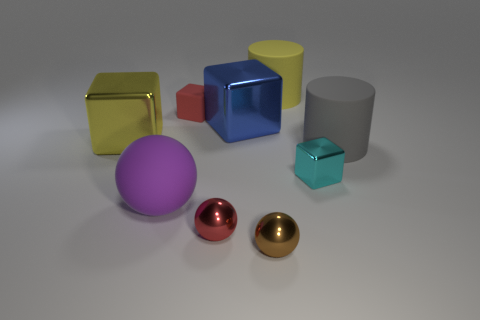Subtract all matte spheres. How many spheres are left? 2 Subtract all yellow blocks. How many blocks are left? 3 Add 1 large brown matte spheres. How many objects exist? 10 Subtract 3 cubes. How many cubes are left? 1 Subtract all cylinders. How many objects are left? 7 Subtract all purple cylinders. How many blue cubes are left? 1 Subtract all small rubber blocks. Subtract all blue rubber cylinders. How many objects are left? 8 Add 5 red rubber objects. How many red rubber objects are left? 6 Add 3 big yellow cubes. How many big yellow cubes exist? 4 Subtract 1 red balls. How many objects are left? 8 